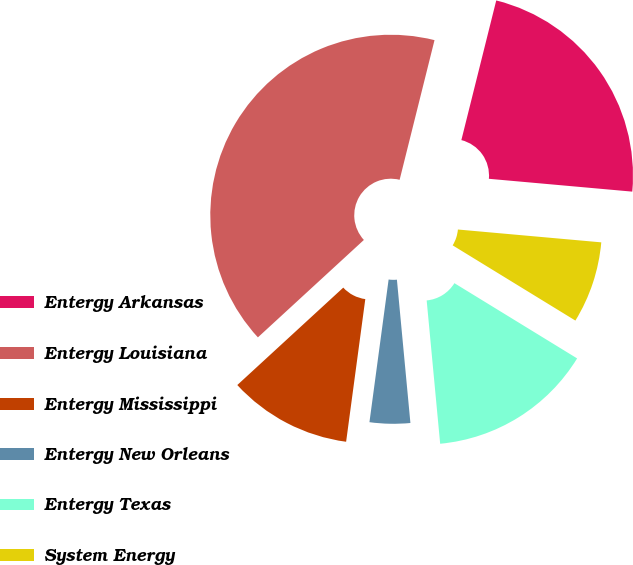Convert chart. <chart><loc_0><loc_0><loc_500><loc_500><pie_chart><fcel>Entergy Arkansas<fcel>Entergy Louisiana<fcel>Entergy Mississippi<fcel>Entergy New Orleans<fcel>Entergy Texas<fcel>System Energy<nl><fcel>22.52%<fcel>40.72%<fcel>11.04%<fcel>3.62%<fcel>14.75%<fcel>7.33%<nl></chart> 